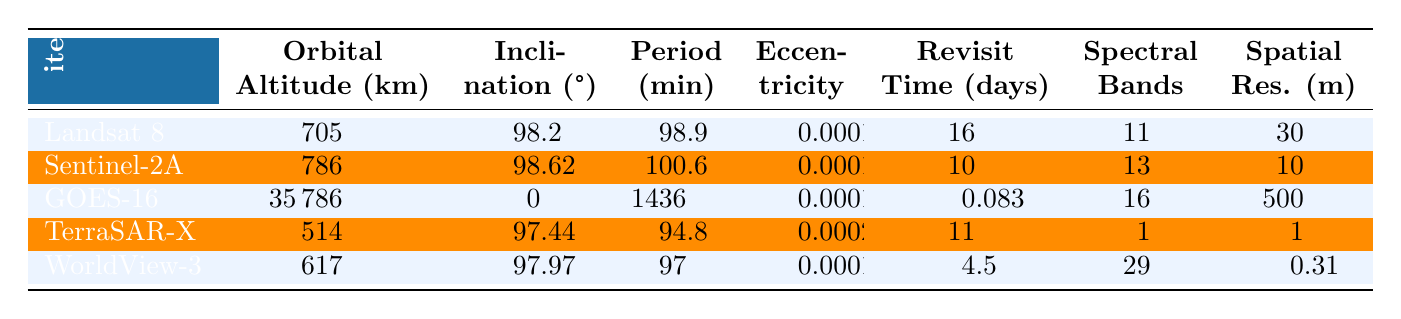What is the orbital altitude of Landsat 8? The table lists the orbital altitude of Landsat 8 as 705 km in the "Orbital Altitude (km)" column.
Answer: 705 km Which satellite has the highest inclination? By comparing the "Inclination (°)" values, Sentinel-2A has the highest inclination at 98.62°.
Answer: 98.62° What is the revisit time of GOES-16? The table specifies that the revisit time for GOES-16 is 0.083 days in the "Revisit Time (days)" column.
Answer: 0.083 days How many spectral bands does WorldView-3 have? According to the table, WorldView-3 has 29 spectral bands in the "Spectral Bands" column.
Answer: 29 What is the average orbital altitude of all the satellites? The orbital altitudes are 705, 786, 35786, 514, and 617 km. Adding these gives 40008 km, and dividing by 5 (the number of satellites) results in an average of 8001.6 km.
Answer: 8001.6 km Which satellite has the shortest spatial resolution? In the "Spatial Res. (m)" column, TerraSAR-X has the shortest spatial resolution at 1 meter.
Answer: 1 meter Do all satellites have an eccentricity of 0.0001? By inspecting the "Eccentricity" values, only Landsat 8, Sentinel-2A, and GOES-16 have an eccentricity of 0.0001; TerraSAR-X has 0.0002, making the statement false.
Answer: No Which satellite has the lowest revisit time and how does it compare to others? GOES-16 has the lowest revisit time of 0.083 days, which is significantly lower than the others, especially WorldView-3 (4.5 days) and Landsat 8 (16 days).
Answer: GOES-16 has the lowest revisit time Is there a relationship between orbital altitude and revisit time for these satellites? Upon examination, there is no clear correlation; for instance, Landsat 8 (705 km) has a long revisit time of 16 days, while GOES-16 (35786 km) has a very short revisit time of 0.083 days, indicating no straightforward relationship.
Answer: No clear relationship What is the total number of spectral bands for all satellites combined? Summing the spectral bands across the satellites, we calculate: 11 (Landsat 8) + 13 (Sentinel-2A) + 16 (GOES-16) + 1 (TerraSAR-X) + 29 (WorldView-3) which equals 70.
Answer: 70 